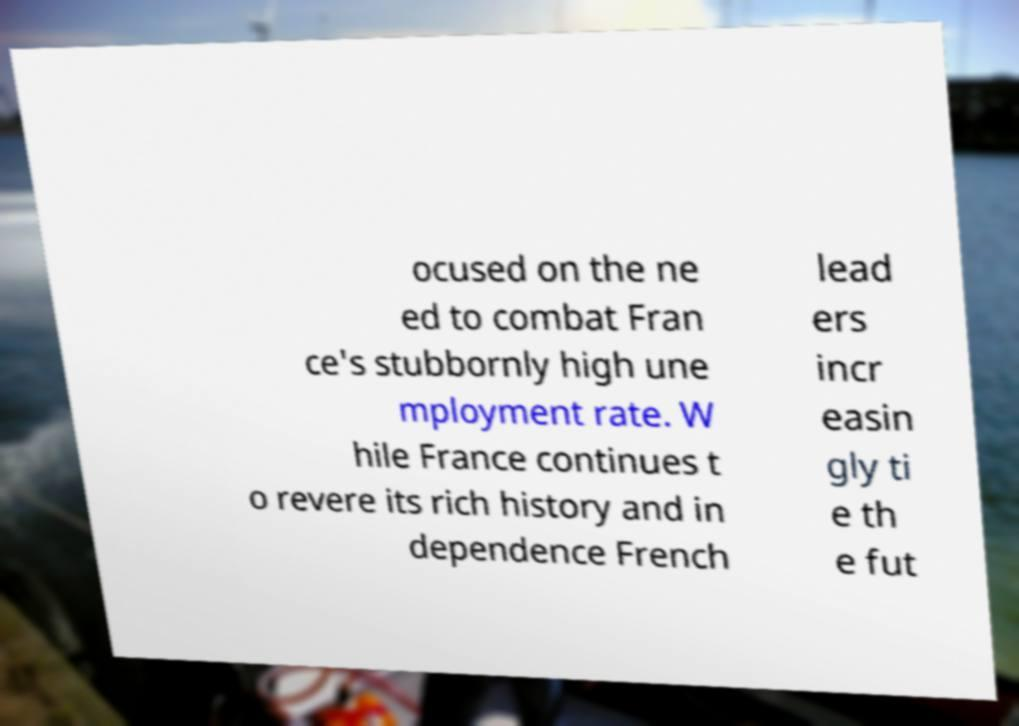Can you read and provide the text displayed in the image?This photo seems to have some interesting text. Can you extract and type it out for me? ocused on the ne ed to combat Fran ce's stubbornly high une mployment rate. W hile France continues t o revere its rich history and in dependence French lead ers incr easin gly ti e th e fut 